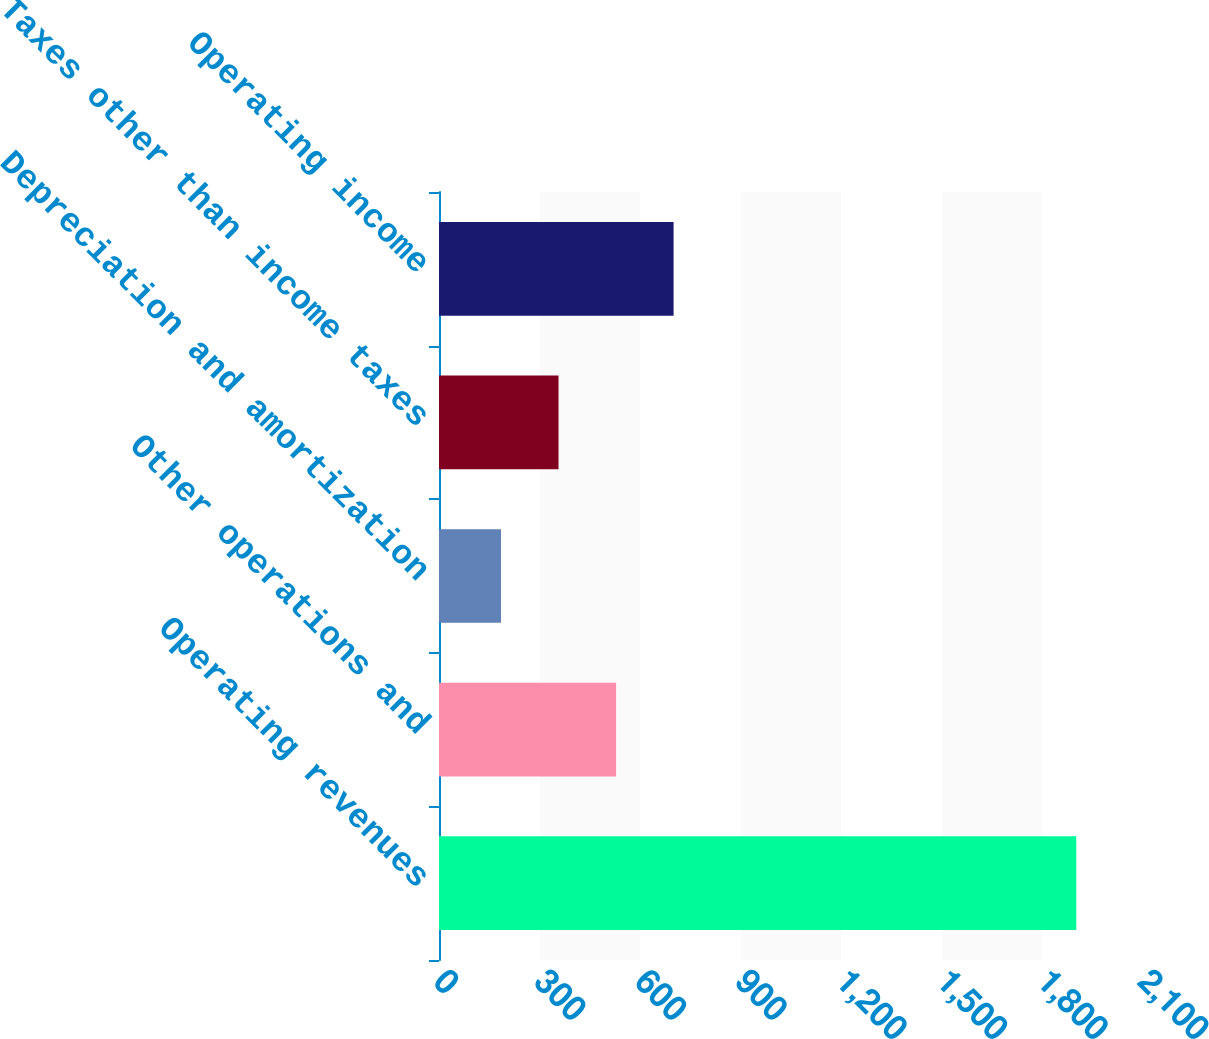Convert chart to OTSL. <chart><loc_0><loc_0><loc_500><loc_500><bar_chart><fcel>Operating revenues<fcel>Other operations and<fcel>Depreciation and amortization<fcel>Taxes other than income taxes<fcel>Operating income<nl><fcel>1901<fcel>528.2<fcel>185<fcel>356.6<fcel>699.8<nl></chart> 